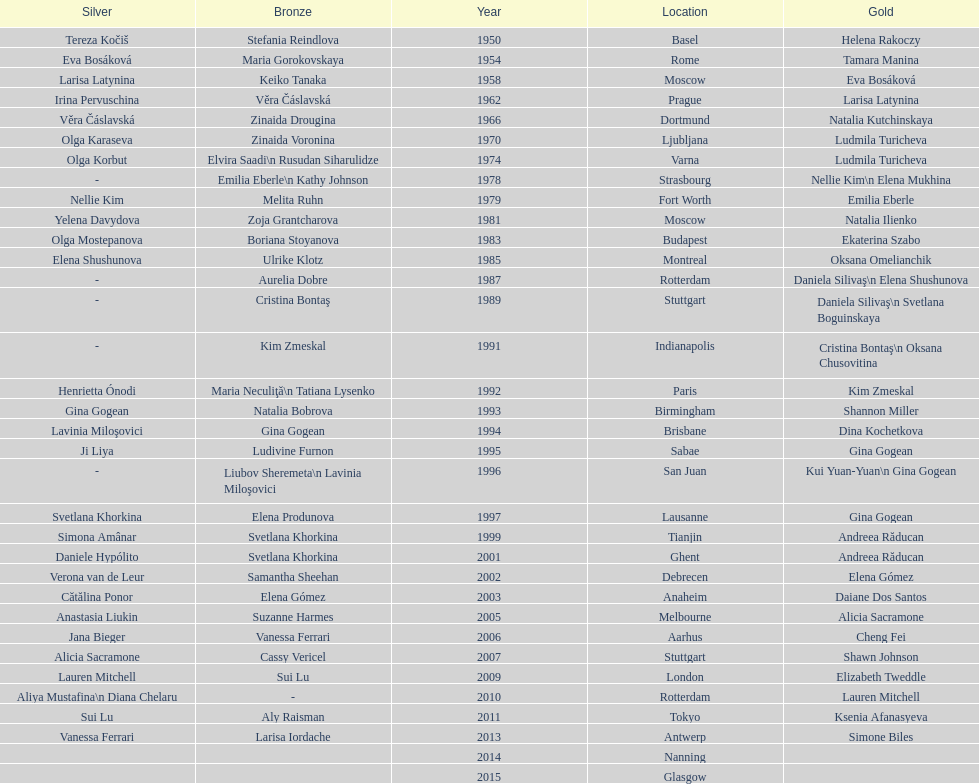Where did the world artistic gymnastics take place before san juan? Sabae. 